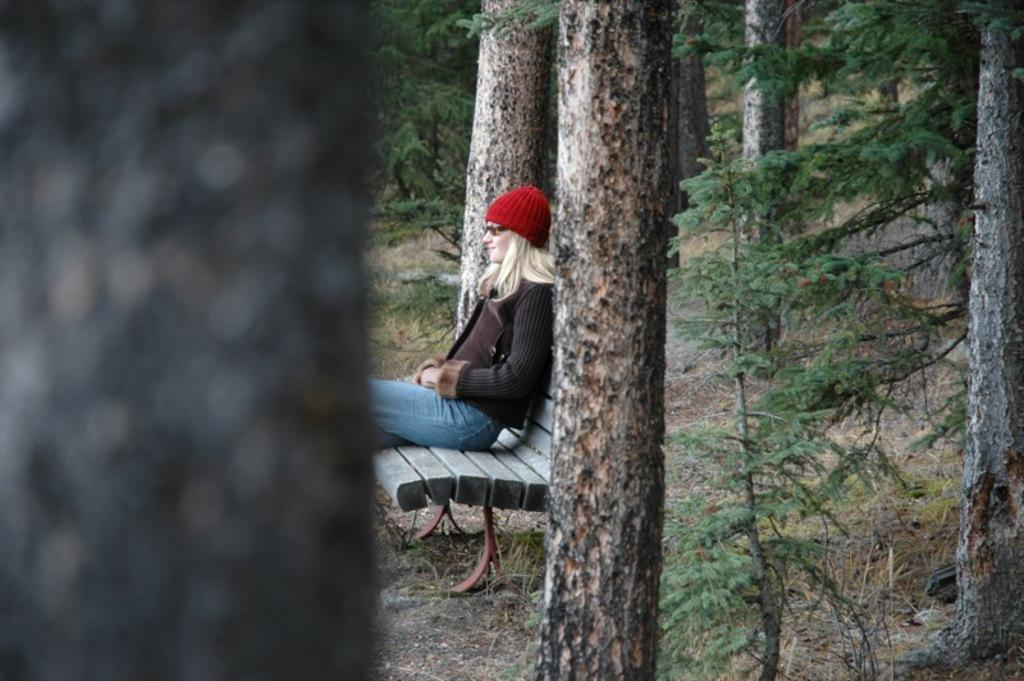What is the woman doing in the image? The woman is sitting on a bench in the image. What is the woman wearing on her head? The woman is wearing a red cap in the image. What type of eyewear is the woman wearing? The woman is wearing goggles in the image. What type of clothing is the woman wearing on her upper body? The woman is wearing a sweater in the image. What type of pants is the woman wearing? The woman is wearing blue denim pants in the image. What type of natural environment is visible around the woman? There are trees and plants around the woman in the image. What type of wine is the woman drinking in the image? There is no wine present in the image; the woman is not holding or drinking any wine. 